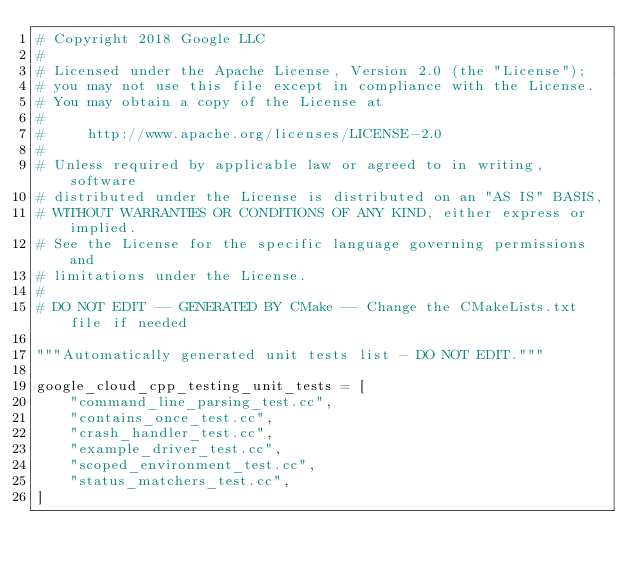<code> <loc_0><loc_0><loc_500><loc_500><_Python_># Copyright 2018 Google LLC
#
# Licensed under the Apache License, Version 2.0 (the "License");
# you may not use this file except in compliance with the License.
# You may obtain a copy of the License at
#
#     http://www.apache.org/licenses/LICENSE-2.0
#
# Unless required by applicable law or agreed to in writing, software
# distributed under the License is distributed on an "AS IS" BASIS,
# WITHOUT WARRANTIES OR CONDITIONS OF ANY KIND, either express or implied.
# See the License for the specific language governing permissions and
# limitations under the License.
#
# DO NOT EDIT -- GENERATED BY CMake -- Change the CMakeLists.txt file if needed

"""Automatically generated unit tests list - DO NOT EDIT."""

google_cloud_cpp_testing_unit_tests = [
    "command_line_parsing_test.cc",
    "contains_once_test.cc",
    "crash_handler_test.cc",
    "example_driver_test.cc",
    "scoped_environment_test.cc",
    "status_matchers_test.cc",
]
</code> 